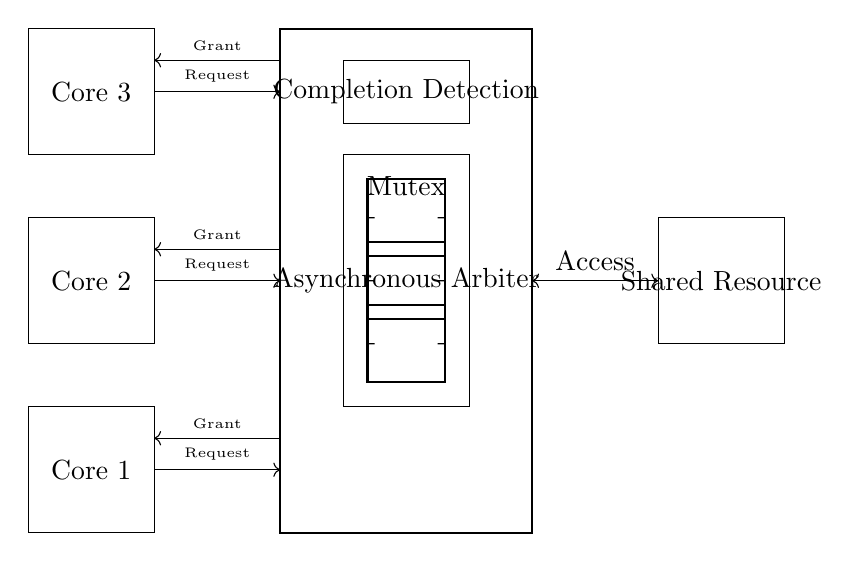What components are present in the asynchronous arbiter design? The components visible in the circuit are three cores, an asynchronous arbiter, a shared resource, a mutex, and a completion detection unit. Each component is drawn distinctly, representing parts of the circuit dedicated to managing multi-core processor access.
Answer: Three cores, asynchronous arbiter, shared resource, mutex, completion detection What is the function of the mutex in this circuit? The mutex (mutual exclusion) controls access to the shared resource among the cores, ensuring that only one core accesses the resource at a time to prevent conflicts or data corruption.
Answer: Control access to shared resource How many requests are made to the arbiter by the cores? Each of the three cores sends a request to the arbiter, which means there are a total of three request lines leading to the arbiter from the cores.
Answer: Three requests What type of access is represented between the arbiter and the shared resource? The connection between the arbiter and the shared resource is bi-directional, indicated by the double-headed arrow labeled 'Access,' allowing read/write operations to be controlled by the arbiter for the shared resource.
Answer: Bi-directional access What is the role of the completion detection unit in the design? The completion detection unit monitors the status of the resource access by cores, signaling when an operation on the shared resource has been completed, allowing the arbiter to grant access to the next requesting core.
Answer: Monitors resource access completion What type of signal does each core send to the arbiter? Each core sends a 'Request' signal to the arbiter, which denotes a need for accessing the shared resource, indicating a demand for control over the resource.
Answer: Request signal How does the arbiter respond to the requests from the cores? The arbiter grants access back to the requesting cores through 'Grant' signals, allowing the core that has been granted permission to use the shared resource, reflecting the asynchronous nature of the control.
Answer: Grant signals 